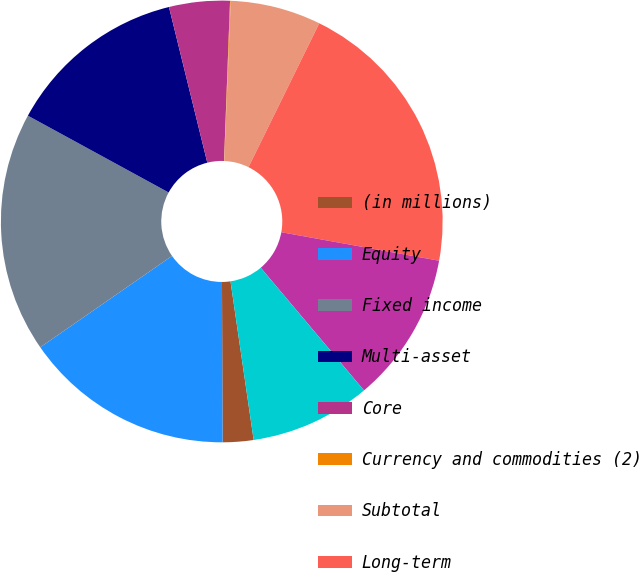Convert chart. <chart><loc_0><loc_0><loc_500><loc_500><pie_chart><fcel>(in millions)<fcel>Equity<fcel>Fixed income<fcel>Multi-asset<fcel>Core<fcel>Currency and commodities (2)<fcel>Subtotal<fcel>Long-term<fcel>Cash management<fcel>Advisory (1)<nl><fcel>2.25%<fcel>15.41%<fcel>17.6%<fcel>13.21%<fcel>4.44%<fcel>0.05%<fcel>6.63%<fcel>20.57%<fcel>11.02%<fcel>8.83%<nl></chart> 